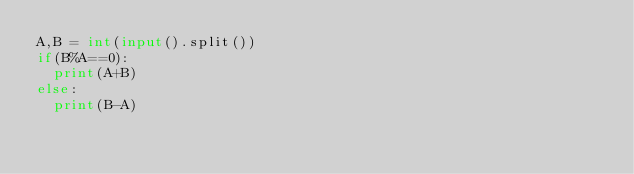Convert code to text. <code><loc_0><loc_0><loc_500><loc_500><_Python_>A,B = int(input().split())
if(B%A==0):
  print(A+B)
else:
  print(B-A)</code> 